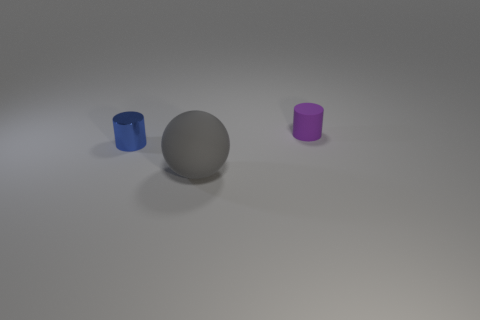Is there anything else that has the same material as the blue object?
Your answer should be compact. No. There is a cylinder that is on the right side of the cylinder that is in front of the cylinder that is on the right side of the tiny blue cylinder; what is its size?
Provide a short and direct response. Small. How many matte cylinders are the same size as the blue metallic thing?
Give a very brief answer. 1. What number of things are tiny green blocks or small objects that are behind the small blue thing?
Offer a terse response. 1. The blue thing has what shape?
Your answer should be compact. Cylinder. There is a shiny object that is the same size as the purple rubber cylinder; what is its color?
Your response must be concise. Blue. What number of purple objects are rubber objects or large metal objects?
Ensure brevity in your answer.  1. Is the number of matte spheres greater than the number of tiny cylinders?
Offer a very short reply. No. Does the object in front of the small blue metallic cylinder have the same size as the cylinder that is in front of the purple thing?
Your answer should be very brief. No. What is the color of the matte thing that is on the left side of the tiny object behind the small thing that is in front of the tiny purple thing?
Keep it short and to the point. Gray. 